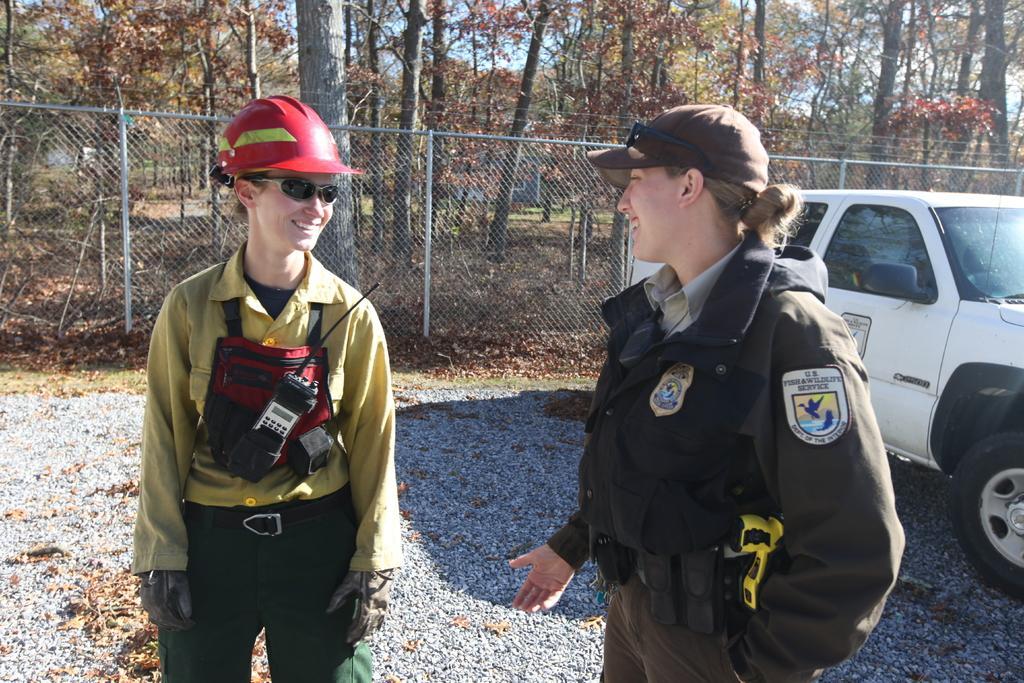Please provide a concise description of this image. In the image there are two women standing and talking to each other, It looks like they are on duty and behind them there is a vehicle, behind the vehicle there is a fence and behind the fence there are plenty of trees. 